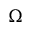Convert formula to latex. <formula><loc_0><loc_0><loc_500><loc_500>\Omega</formula> 